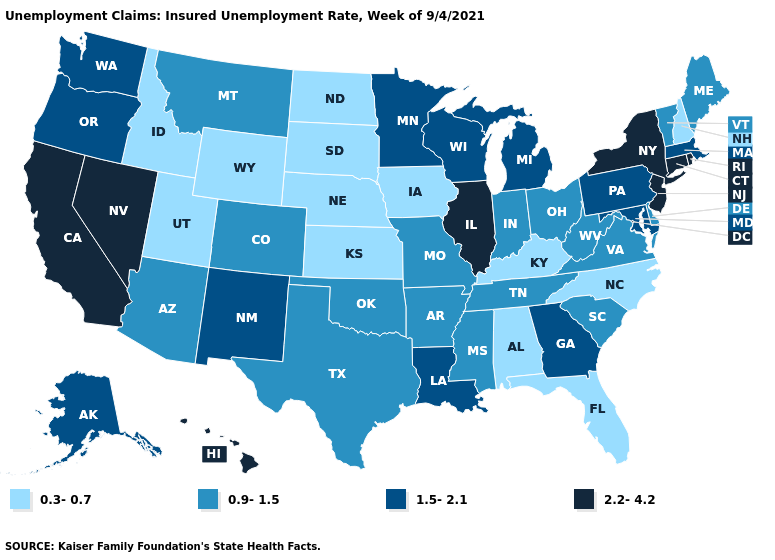Among the states that border Florida , which have the lowest value?
Write a very short answer. Alabama. What is the lowest value in the Northeast?
Give a very brief answer. 0.3-0.7. How many symbols are there in the legend?
Be succinct. 4. Does North Carolina have the same value as Indiana?
Keep it brief. No. Name the states that have a value in the range 0.3-0.7?
Short answer required. Alabama, Florida, Idaho, Iowa, Kansas, Kentucky, Nebraska, New Hampshire, North Carolina, North Dakota, South Dakota, Utah, Wyoming. Does Montana have the highest value in the USA?
Short answer required. No. Name the states that have a value in the range 0.9-1.5?
Write a very short answer. Arizona, Arkansas, Colorado, Delaware, Indiana, Maine, Mississippi, Missouri, Montana, Ohio, Oklahoma, South Carolina, Tennessee, Texas, Vermont, Virginia, West Virginia. Does North Carolina have a lower value than Iowa?
Write a very short answer. No. Name the states that have a value in the range 0.3-0.7?
Be succinct. Alabama, Florida, Idaho, Iowa, Kansas, Kentucky, Nebraska, New Hampshire, North Carolina, North Dakota, South Dakota, Utah, Wyoming. Does Alaska have a lower value than Wisconsin?
Keep it brief. No. Is the legend a continuous bar?
Write a very short answer. No. What is the value of Arizona?
Concise answer only. 0.9-1.5. What is the value of South Dakota?
Give a very brief answer. 0.3-0.7. What is the lowest value in the USA?
Keep it brief. 0.3-0.7. Does the map have missing data?
Short answer required. No. 